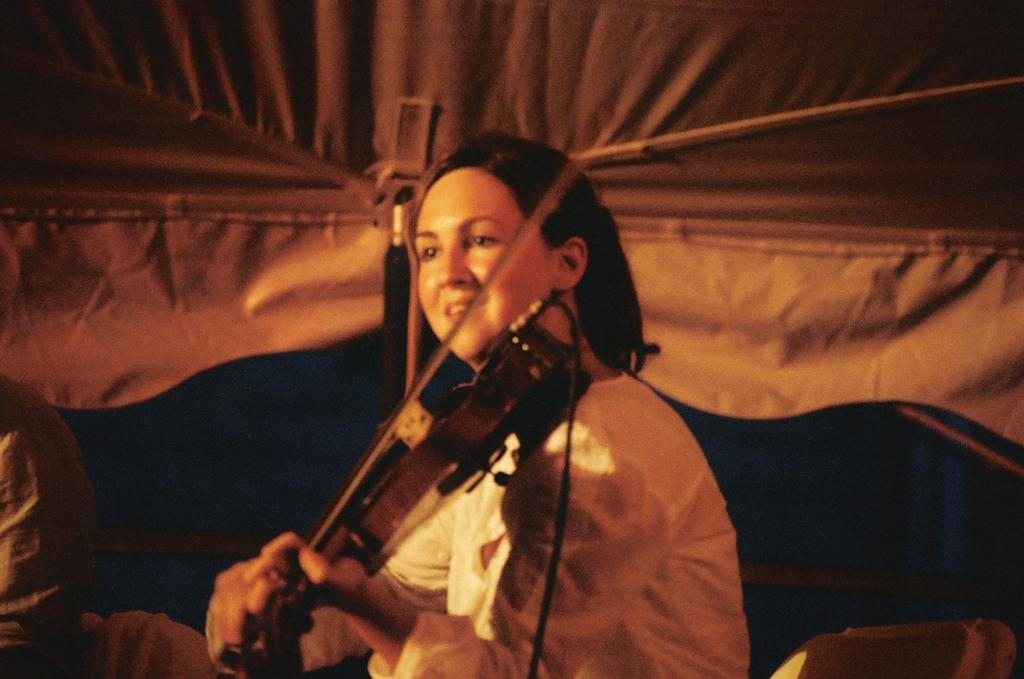What is the woman in the image doing? The woman is playing the violin in the image. How does the woman appear to feel while playing the violin? The woman is smiling, which suggests she is enjoying herself. Where is the woman located in the image? The woman is under a tent in the image. Can you describe the presence of another person in the image? Yes, there is another person in the image, but their specific actions or appearance are not mentioned in the provided facts. What type of leather can be seen on the stage in the image? There is no stage or leather present in the image; it features a woman playing the violin under a tent. 